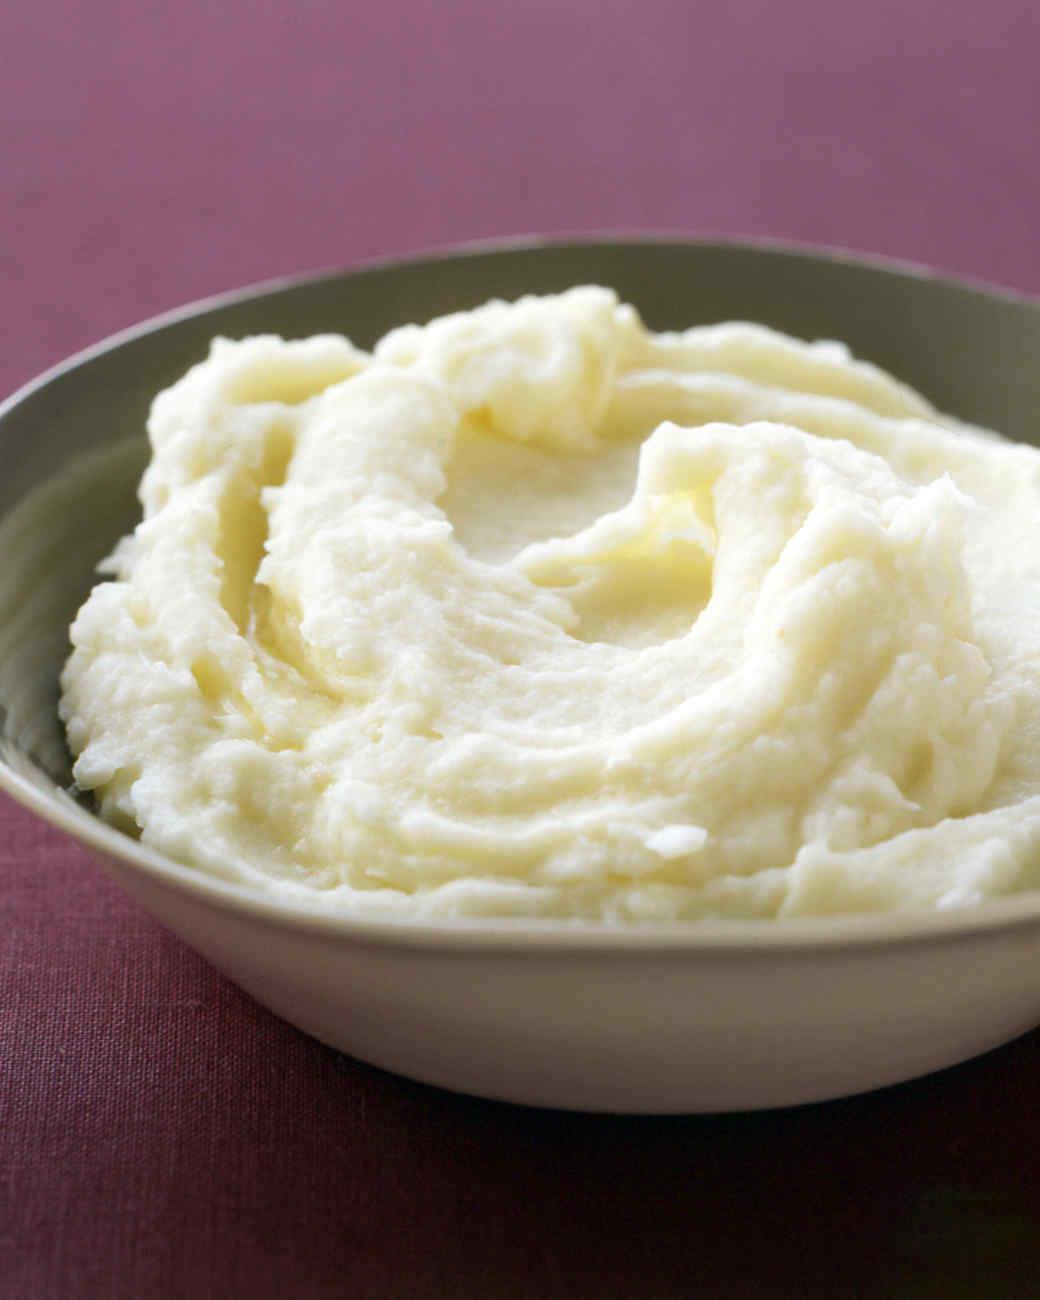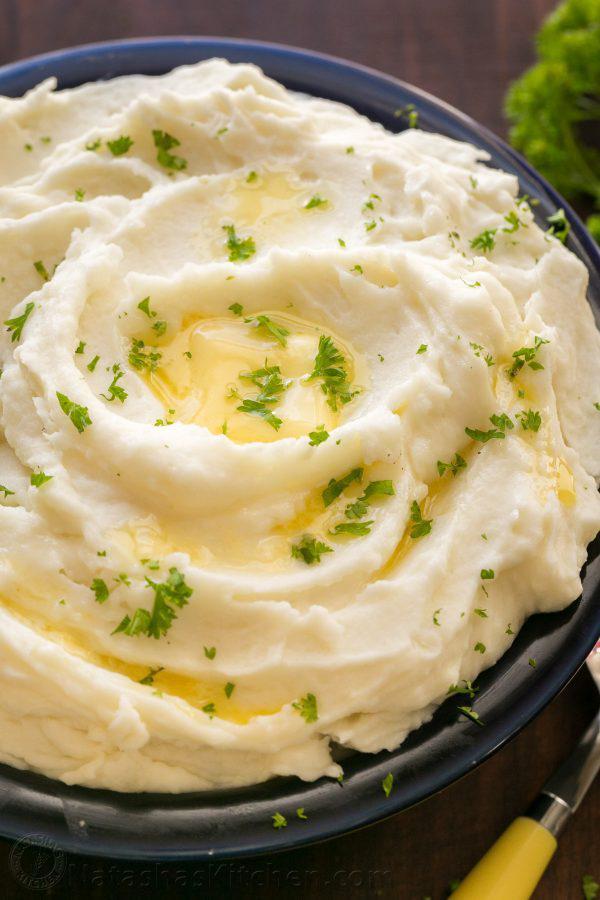The first image is the image on the left, the second image is the image on the right. Given the left and right images, does the statement "the bowl on the left image is all white" hold true? Answer yes or no. No. 